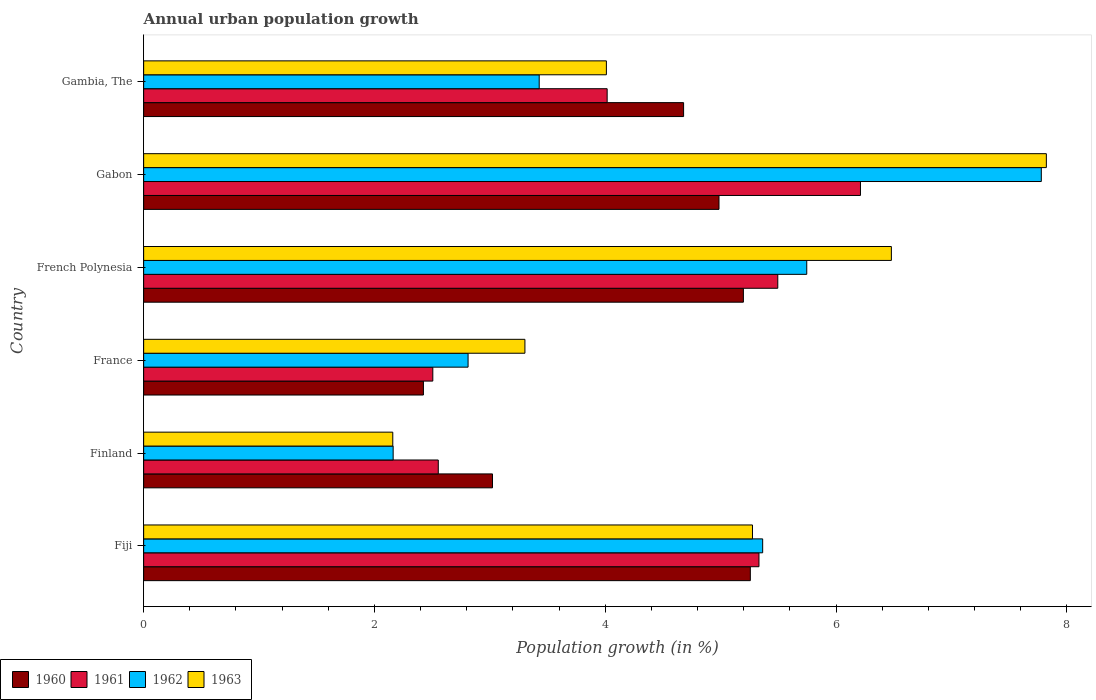How many different coloured bars are there?
Provide a short and direct response. 4. How many groups of bars are there?
Offer a terse response. 6. Are the number of bars per tick equal to the number of legend labels?
Your answer should be very brief. Yes. Are the number of bars on each tick of the Y-axis equal?
Provide a short and direct response. Yes. How many bars are there on the 2nd tick from the bottom?
Offer a terse response. 4. What is the label of the 2nd group of bars from the top?
Provide a succinct answer. Gabon. What is the percentage of urban population growth in 1960 in Gambia, The?
Offer a terse response. 4.68. Across all countries, what is the maximum percentage of urban population growth in 1962?
Your response must be concise. 7.78. Across all countries, what is the minimum percentage of urban population growth in 1963?
Your response must be concise. 2.16. In which country was the percentage of urban population growth in 1962 maximum?
Provide a short and direct response. Gabon. What is the total percentage of urban population growth in 1960 in the graph?
Keep it short and to the point. 25.57. What is the difference between the percentage of urban population growth in 1961 in Fiji and that in France?
Provide a short and direct response. 2.83. What is the difference between the percentage of urban population growth in 1961 in Fiji and the percentage of urban population growth in 1962 in Finland?
Keep it short and to the point. 3.17. What is the average percentage of urban population growth in 1961 per country?
Provide a short and direct response. 4.35. What is the difference between the percentage of urban population growth in 1962 and percentage of urban population growth in 1960 in Fiji?
Give a very brief answer. 0.11. What is the ratio of the percentage of urban population growth in 1963 in Fiji to that in Gabon?
Keep it short and to the point. 0.67. Is the difference between the percentage of urban population growth in 1962 in Finland and French Polynesia greater than the difference between the percentage of urban population growth in 1960 in Finland and French Polynesia?
Offer a very short reply. No. What is the difference between the highest and the second highest percentage of urban population growth in 1963?
Make the answer very short. 1.34. What is the difference between the highest and the lowest percentage of urban population growth in 1963?
Your response must be concise. 5.66. In how many countries, is the percentage of urban population growth in 1963 greater than the average percentage of urban population growth in 1963 taken over all countries?
Your answer should be compact. 3. Is it the case that in every country, the sum of the percentage of urban population growth in 1961 and percentage of urban population growth in 1963 is greater than the sum of percentage of urban population growth in 1962 and percentage of urban population growth in 1960?
Offer a terse response. No. What does the 1st bar from the top in France represents?
Keep it short and to the point. 1963. What does the 4th bar from the bottom in France represents?
Your answer should be compact. 1963. Is it the case that in every country, the sum of the percentage of urban population growth in 1963 and percentage of urban population growth in 1961 is greater than the percentage of urban population growth in 1962?
Offer a terse response. Yes. How many bars are there?
Offer a terse response. 24. Are all the bars in the graph horizontal?
Provide a succinct answer. Yes. Are the values on the major ticks of X-axis written in scientific E-notation?
Your response must be concise. No. Does the graph contain grids?
Keep it short and to the point. No. Where does the legend appear in the graph?
Give a very brief answer. Bottom left. How many legend labels are there?
Your answer should be compact. 4. How are the legend labels stacked?
Offer a terse response. Horizontal. What is the title of the graph?
Your answer should be very brief. Annual urban population growth. What is the label or title of the X-axis?
Provide a short and direct response. Population growth (in %). What is the label or title of the Y-axis?
Ensure brevity in your answer.  Country. What is the Population growth (in %) of 1960 in Fiji?
Keep it short and to the point. 5.26. What is the Population growth (in %) in 1961 in Fiji?
Offer a very short reply. 5.33. What is the Population growth (in %) of 1962 in Fiji?
Ensure brevity in your answer.  5.36. What is the Population growth (in %) in 1963 in Fiji?
Provide a succinct answer. 5.28. What is the Population growth (in %) of 1960 in Finland?
Offer a very short reply. 3.02. What is the Population growth (in %) of 1961 in Finland?
Your answer should be compact. 2.55. What is the Population growth (in %) in 1962 in Finland?
Make the answer very short. 2.16. What is the Population growth (in %) of 1963 in Finland?
Give a very brief answer. 2.16. What is the Population growth (in %) in 1960 in France?
Offer a terse response. 2.42. What is the Population growth (in %) in 1961 in France?
Give a very brief answer. 2.51. What is the Population growth (in %) of 1962 in France?
Offer a terse response. 2.81. What is the Population growth (in %) of 1963 in France?
Give a very brief answer. 3.3. What is the Population growth (in %) in 1960 in French Polynesia?
Offer a very short reply. 5.2. What is the Population growth (in %) in 1961 in French Polynesia?
Provide a short and direct response. 5.5. What is the Population growth (in %) in 1962 in French Polynesia?
Your response must be concise. 5.75. What is the Population growth (in %) in 1963 in French Polynesia?
Your response must be concise. 6.48. What is the Population growth (in %) in 1960 in Gabon?
Your response must be concise. 4.99. What is the Population growth (in %) in 1961 in Gabon?
Offer a terse response. 6.21. What is the Population growth (in %) of 1962 in Gabon?
Your answer should be very brief. 7.78. What is the Population growth (in %) in 1963 in Gabon?
Provide a succinct answer. 7.82. What is the Population growth (in %) of 1960 in Gambia, The?
Offer a terse response. 4.68. What is the Population growth (in %) in 1961 in Gambia, The?
Your response must be concise. 4.02. What is the Population growth (in %) in 1962 in Gambia, The?
Your answer should be very brief. 3.43. What is the Population growth (in %) in 1963 in Gambia, The?
Give a very brief answer. 4.01. Across all countries, what is the maximum Population growth (in %) in 1960?
Your response must be concise. 5.26. Across all countries, what is the maximum Population growth (in %) of 1961?
Offer a terse response. 6.21. Across all countries, what is the maximum Population growth (in %) of 1962?
Offer a very short reply. 7.78. Across all countries, what is the maximum Population growth (in %) in 1963?
Your response must be concise. 7.82. Across all countries, what is the minimum Population growth (in %) in 1960?
Offer a terse response. 2.42. Across all countries, what is the minimum Population growth (in %) of 1961?
Your response must be concise. 2.51. Across all countries, what is the minimum Population growth (in %) in 1962?
Your answer should be very brief. 2.16. Across all countries, what is the minimum Population growth (in %) in 1963?
Keep it short and to the point. 2.16. What is the total Population growth (in %) in 1960 in the graph?
Offer a terse response. 25.57. What is the total Population growth (in %) in 1961 in the graph?
Your answer should be very brief. 26.12. What is the total Population growth (in %) in 1962 in the graph?
Give a very brief answer. 27.29. What is the total Population growth (in %) in 1963 in the graph?
Give a very brief answer. 29.05. What is the difference between the Population growth (in %) of 1960 in Fiji and that in Finland?
Offer a terse response. 2.23. What is the difference between the Population growth (in %) in 1961 in Fiji and that in Finland?
Give a very brief answer. 2.78. What is the difference between the Population growth (in %) of 1962 in Fiji and that in Finland?
Ensure brevity in your answer.  3.2. What is the difference between the Population growth (in %) of 1963 in Fiji and that in Finland?
Provide a succinct answer. 3.12. What is the difference between the Population growth (in %) of 1960 in Fiji and that in France?
Provide a short and direct response. 2.83. What is the difference between the Population growth (in %) in 1961 in Fiji and that in France?
Make the answer very short. 2.83. What is the difference between the Population growth (in %) in 1962 in Fiji and that in France?
Ensure brevity in your answer.  2.55. What is the difference between the Population growth (in %) of 1963 in Fiji and that in France?
Provide a short and direct response. 1.97. What is the difference between the Population growth (in %) in 1960 in Fiji and that in French Polynesia?
Provide a succinct answer. 0.06. What is the difference between the Population growth (in %) of 1961 in Fiji and that in French Polynesia?
Keep it short and to the point. -0.16. What is the difference between the Population growth (in %) in 1962 in Fiji and that in French Polynesia?
Your response must be concise. -0.38. What is the difference between the Population growth (in %) in 1963 in Fiji and that in French Polynesia?
Your answer should be very brief. -1.2. What is the difference between the Population growth (in %) of 1960 in Fiji and that in Gabon?
Keep it short and to the point. 0.27. What is the difference between the Population growth (in %) in 1961 in Fiji and that in Gabon?
Make the answer very short. -0.88. What is the difference between the Population growth (in %) of 1962 in Fiji and that in Gabon?
Your answer should be compact. -2.41. What is the difference between the Population growth (in %) in 1963 in Fiji and that in Gabon?
Provide a short and direct response. -2.55. What is the difference between the Population growth (in %) in 1960 in Fiji and that in Gambia, The?
Provide a short and direct response. 0.58. What is the difference between the Population growth (in %) of 1961 in Fiji and that in Gambia, The?
Ensure brevity in your answer.  1.32. What is the difference between the Population growth (in %) of 1962 in Fiji and that in Gambia, The?
Give a very brief answer. 1.94. What is the difference between the Population growth (in %) in 1963 in Fiji and that in Gambia, The?
Keep it short and to the point. 1.27. What is the difference between the Population growth (in %) of 1960 in Finland and that in France?
Offer a terse response. 0.6. What is the difference between the Population growth (in %) in 1961 in Finland and that in France?
Provide a succinct answer. 0.05. What is the difference between the Population growth (in %) in 1962 in Finland and that in France?
Give a very brief answer. -0.65. What is the difference between the Population growth (in %) in 1963 in Finland and that in France?
Make the answer very short. -1.15. What is the difference between the Population growth (in %) in 1960 in Finland and that in French Polynesia?
Your answer should be very brief. -2.17. What is the difference between the Population growth (in %) in 1961 in Finland and that in French Polynesia?
Your response must be concise. -2.94. What is the difference between the Population growth (in %) of 1962 in Finland and that in French Polynesia?
Offer a terse response. -3.58. What is the difference between the Population growth (in %) in 1963 in Finland and that in French Polynesia?
Your answer should be compact. -4.32. What is the difference between the Population growth (in %) of 1960 in Finland and that in Gabon?
Keep it short and to the point. -1.96. What is the difference between the Population growth (in %) in 1961 in Finland and that in Gabon?
Your response must be concise. -3.66. What is the difference between the Population growth (in %) in 1962 in Finland and that in Gabon?
Offer a very short reply. -5.62. What is the difference between the Population growth (in %) in 1963 in Finland and that in Gabon?
Provide a short and direct response. -5.66. What is the difference between the Population growth (in %) in 1960 in Finland and that in Gambia, The?
Your response must be concise. -1.66. What is the difference between the Population growth (in %) of 1961 in Finland and that in Gambia, The?
Make the answer very short. -1.46. What is the difference between the Population growth (in %) in 1962 in Finland and that in Gambia, The?
Your answer should be very brief. -1.27. What is the difference between the Population growth (in %) in 1963 in Finland and that in Gambia, The?
Offer a terse response. -1.85. What is the difference between the Population growth (in %) in 1960 in France and that in French Polynesia?
Offer a terse response. -2.77. What is the difference between the Population growth (in %) of 1961 in France and that in French Polynesia?
Keep it short and to the point. -2.99. What is the difference between the Population growth (in %) in 1962 in France and that in French Polynesia?
Offer a terse response. -2.94. What is the difference between the Population growth (in %) in 1963 in France and that in French Polynesia?
Provide a succinct answer. -3.18. What is the difference between the Population growth (in %) in 1960 in France and that in Gabon?
Give a very brief answer. -2.56. What is the difference between the Population growth (in %) in 1961 in France and that in Gabon?
Ensure brevity in your answer.  -3.71. What is the difference between the Population growth (in %) in 1962 in France and that in Gabon?
Make the answer very short. -4.97. What is the difference between the Population growth (in %) of 1963 in France and that in Gabon?
Your answer should be compact. -4.52. What is the difference between the Population growth (in %) of 1960 in France and that in Gambia, The?
Your response must be concise. -2.25. What is the difference between the Population growth (in %) of 1961 in France and that in Gambia, The?
Offer a very short reply. -1.51. What is the difference between the Population growth (in %) in 1962 in France and that in Gambia, The?
Your answer should be very brief. -0.62. What is the difference between the Population growth (in %) in 1963 in France and that in Gambia, The?
Ensure brevity in your answer.  -0.71. What is the difference between the Population growth (in %) of 1960 in French Polynesia and that in Gabon?
Offer a very short reply. 0.21. What is the difference between the Population growth (in %) of 1961 in French Polynesia and that in Gabon?
Keep it short and to the point. -0.72. What is the difference between the Population growth (in %) in 1962 in French Polynesia and that in Gabon?
Your answer should be very brief. -2.03. What is the difference between the Population growth (in %) of 1963 in French Polynesia and that in Gabon?
Make the answer very short. -1.34. What is the difference between the Population growth (in %) of 1960 in French Polynesia and that in Gambia, The?
Keep it short and to the point. 0.52. What is the difference between the Population growth (in %) of 1961 in French Polynesia and that in Gambia, The?
Ensure brevity in your answer.  1.48. What is the difference between the Population growth (in %) of 1962 in French Polynesia and that in Gambia, The?
Provide a succinct answer. 2.32. What is the difference between the Population growth (in %) of 1963 in French Polynesia and that in Gambia, The?
Provide a succinct answer. 2.47. What is the difference between the Population growth (in %) in 1960 in Gabon and that in Gambia, The?
Provide a short and direct response. 0.31. What is the difference between the Population growth (in %) in 1961 in Gabon and that in Gambia, The?
Your response must be concise. 2.2. What is the difference between the Population growth (in %) in 1962 in Gabon and that in Gambia, The?
Your answer should be very brief. 4.35. What is the difference between the Population growth (in %) in 1963 in Gabon and that in Gambia, The?
Ensure brevity in your answer.  3.81. What is the difference between the Population growth (in %) in 1960 in Fiji and the Population growth (in %) in 1961 in Finland?
Give a very brief answer. 2.7. What is the difference between the Population growth (in %) in 1960 in Fiji and the Population growth (in %) in 1962 in Finland?
Provide a short and direct response. 3.1. What is the difference between the Population growth (in %) in 1960 in Fiji and the Population growth (in %) in 1963 in Finland?
Make the answer very short. 3.1. What is the difference between the Population growth (in %) in 1961 in Fiji and the Population growth (in %) in 1962 in Finland?
Ensure brevity in your answer.  3.17. What is the difference between the Population growth (in %) of 1961 in Fiji and the Population growth (in %) of 1963 in Finland?
Offer a terse response. 3.17. What is the difference between the Population growth (in %) of 1962 in Fiji and the Population growth (in %) of 1963 in Finland?
Make the answer very short. 3.21. What is the difference between the Population growth (in %) of 1960 in Fiji and the Population growth (in %) of 1961 in France?
Your answer should be very brief. 2.75. What is the difference between the Population growth (in %) in 1960 in Fiji and the Population growth (in %) in 1962 in France?
Offer a terse response. 2.45. What is the difference between the Population growth (in %) of 1960 in Fiji and the Population growth (in %) of 1963 in France?
Your answer should be compact. 1.95. What is the difference between the Population growth (in %) of 1961 in Fiji and the Population growth (in %) of 1962 in France?
Your answer should be very brief. 2.52. What is the difference between the Population growth (in %) of 1961 in Fiji and the Population growth (in %) of 1963 in France?
Provide a short and direct response. 2.03. What is the difference between the Population growth (in %) in 1962 in Fiji and the Population growth (in %) in 1963 in France?
Give a very brief answer. 2.06. What is the difference between the Population growth (in %) of 1960 in Fiji and the Population growth (in %) of 1961 in French Polynesia?
Your response must be concise. -0.24. What is the difference between the Population growth (in %) in 1960 in Fiji and the Population growth (in %) in 1962 in French Polynesia?
Offer a very short reply. -0.49. What is the difference between the Population growth (in %) in 1960 in Fiji and the Population growth (in %) in 1963 in French Polynesia?
Ensure brevity in your answer.  -1.22. What is the difference between the Population growth (in %) in 1961 in Fiji and the Population growth (in %) in 1962 in French Polynesia?
Ensure brevity in your answer.  -0.41. What is the difference between the Population growth (in %) in 1961 in Fiji and the Population growth (in %) in 1963 in French Polynesia?
Ensure brevity in your answer.  -1.15. What is the difference between the Population growth (in %) of 1962 in Fiji and the Population growth (in %) of 1963 in French Polynesia?
Ensure brevity in your answer.  -1.12. What is the difference between the Population growth (in %) of 1960 in Fiji and the Population growth (in %) of 1961 in Gabon?
Keep it short and to the point. -0.95. What is the difference between the Population growth (in %) of 1960 in Fiji and the Population growth (in %) of 1962 in Gabon?
Keep it short and to the point. -2.52. What is the difference between the Population growth (in %) in 1960 in Fiji and the Population growth (in %) in 1963 in Gabon?
Keep it short and to the point. -2.57. What is the difference between the Population growth (in %) of 1961 in Fiji and the Population growth (in %) of 1962 in Gabon?
Provide a succinct answer. -2.45. What is the difference between the Population growth (in %) in 1961 in Fiji and the Population growth (in %) in 1963 in Gabon?
Keep it short and to the point. -2.49. What is the difference between the Population growth (in %) in 1962 in Fiji and the Population growth (in %) in 1963 in Gabon?
Offer a very short reply. -2.46. What is the difference between the Population growth (in %) of 1960 in Fiji and the Population growth (in %) of 1961 in Gambia, The?
Offer a very short reply. 1.24. What is the difference between the Population growth (in %) in 1960 in Fiji and the Population growth (in %) in 1962 in Gambia, The?
Ensure brevity in your answer.  1.83. What is the difference between the Population growth (in %) in 1960 in Fiji and the Population growth (in %) in 1963 in Gambia, The?
Your answer should be very brief. 1.25. What is the difference between the Population growth (in %) in 1961 in Fiji and the Population growth (in %) in 1962 in Gambia, The?
Offer a very short reply. 1.9. What is the difference between the Population growth (in %) of 1961 in Fiji and the Population growth (in %) of 1963 in Gambia, The?
Keep it short and to the point. 1.32. What is the difference between the Population growth (in %) of 1962 in Fiji and the Population growth (in %) of 1963 in Gambia, The?
Offer a terse response. 1.35. What is the difference between the Population growth (in %) of 1960 in Finland and the Population growth (in %) of 1961 in France?
Your answer should be very brief. 0.52. What is the difference between the Population growth (in %) in 1960 in Finland and the Population growth (in %) in 1962 in France?
Ensure brevity in your answer.  0.21. What is the difference between the Population growth (in %) in 1960 in Finland and the Population growth (in %) in 1963 in France?
Keep it short and to the point. -0.28. What is the difference between the Population growth (in %) of 1961 in Finland and the Population growth (in %) of 1962 in France?
Make the answer very short. -0.26. What is the difference between the Population growth (in %) of 1961 in Finland and the Population growth (in %) of 1963 in France?
Your answer should be compact. -0.75. What is the difference between the Population growth (in %) of 1962 in Finland and the Population growth (in %) of 1963 in France?
Your response must be concise. -1.14. What is the difference between the Population growth (in %) in 1960 in Finland and the Population growth (in %) in 1961 in French Polynesia?
Your answer should be very brief. -2.47. What is the difference between the Population growth (in %) in 1960 in Finland and the Population growth (in %) in 1962 in French Polynesia?
Your answer should be very brief. -2.72. What is the difference between the Population growth (in %) of 1960 in Finland and the Population growth (in %) of 1963 in French Polynesia?
Make the answer very short. -3.46. What is the difference between the Population growth (in %) in 1961 in Finland and the Population growth (in %) in 1962 in French Polynesia?
Ensure brevity in your answer.  -3.19. What is the difference between the Population growth (in %) in 1961 in Finland and the Population growth (in %) in 1963 in French Polynesia?
Keep it short and to the point. -3.93. What is the difference between the Population growth (in %) of 1962 in Finland and the Population growth (in %) of 1963 in French Polynesia?
Ensure brevity in your answer.  -4.32. What is the difference between the Population growth (in %) in 1960 in Finland and the Population growth (in %) in 1961 in Gabon?
Your answer should be very brief. -3.19. What is the difference between the Population growth (in %) of 1960 in Finland and the Population growth (in %) of 1962 in Gabon?
Your answer should be very brief. -4.76. What is the difference between the Population growth (in %) of 1960 in Finland and the Population growth (in %) of 1963 in Gabon?
Your answer should be very brief. -4.8. What is the difference between the Population growth (in %) in 1961 in Finland and the Population growth (in %) in 1962 in Gabon?
Your answer should be compact. -5.23. What is the difference between the Population growth (in %) of 1961 in Finland and the Population growth (in %) of 1963 in Gabon?
Offer a very short reply. -5.27. What is the difference between the Population growth (in %) in 1962 in Finland and the Population growth (in %) in 1963 in Gabon?
Provide a short and direct response. -5.66. What is the difference between the Population growth (in %) of 1960 in Finland and the Population growth (in %) of 1961 in Gambia, The?
Offer a very short reply. -0.99. What is the difference between the Population growth (in %) in 1960 in Finland and the Population growth (in %) in 1962 in Gambia, The?
Your response must be concise. -0.4. What is the difference between the Population growth (in %) of 1960 in Finland and the Population growth (in %) of 1963 in Gambia, The?
Your answer should be compact. -0.99. What is the difference between the Population growth (in %) in 1961 in Finland and the Population growth (in %) in 1962 in Gambia, The?
Provide a short and direct response. -0.87. What is the difference between the Population growth (in %) of 1961 in Finland and the Population growth (in %) of 1963 in Gambia, The?
Your answer should be very brief. -1.46. What is the difference between the Population growth (in %) of 1962 in Finland and the Population growth (in %) of 1963 in Gambia, The?
Offer a very short reply. -1.85. What is the difference between the Population growth (in %) in 1960 in France and the Population growth (in %) in 1961 in French Polynesia?
Provide a short and direct response. -3.07. What is the difference between the Population growth (in %) in 1960 in France and the Population growth (in %) in 1962 in French Polynesia?
Your answer should be very brief. -3.32. What is the difference between the Population growth (in %) in 1960 in France and the Population growth (in %) in 1963 in French Polynesia?
Offer a very short reply. -4.06. What is the difference between the Population growth (in %) in 1961 in France and the Population growth (in %) in 1962 in French Polynesia?
Your response must be concise. -3.24. What is the difference between the Population growth (in %) of 1961 in France and the Population growth (in %) of 1963 in French Polynesia?
Provide a short and direct response. -3.97. What is the difference between the Population growth (in %) of 1962 in France and the Population growth (in %) of 1963 in French Polynesia?
Keep it short and to the point. -3.67. What is the difference between the Population growth (in %) in 1960 in France and the Population growth (in %) in 1961 in Gabon?
Ensure brevity in your answer.  -3.79. What is the difference between the Population growth (in %) in 1960 in France and the Population growth (in %) in 1962 in Gabon?
Provide a succinct answer. -5.35. What is the difference between the Population growth (in %) of 1960 in France and the Population growth (in %) of 1963 in Gabon?
Offer a very short reply. -5.4. What is the difference between the Population growth (in %) of 1961 in France and the Population growth (in %) of 1962 in Gabon?
Offer a very short reply. -5.27. What is the difference between the Population growth (in %) of 1961 in France and the Population growth (in %) of 1963 in Gabon?
Provide a short and direct response. -5.32. What is the difference between the Population growth (in %) of 1962 in France and the Population growth (in %) of 1963 in Gabon?
Provide a short and direct response. -5.01. What is the difference between the Population growth (in %) in 1960 in France and the Population growth (in %) in 1961 in Gambia, The?
Keep it short and to the point. -1.59. What is the difference between the Population growth (in %) of 1960 in France and the Population growth (in %) of 1962 in Gambia, The?
Offer a terse response. -1. What is the difference between the Population growth (in %) of 1960 in France and the Population growth (in %) of 1963 in Gambia, The?
Provide a short and direct response. -1.59. What is the difference between the Population growth (in %) in 1961 in France and the Population growth (in %) in 1962 in Gambia, The?
Provide a short and direct response. -0.92. What is the difference between the Population growth (in %) in 1961 in France and the Population growth (in %) in 1963 in Gambia, The?
Ensure brevity in your answer.  -1.5. What is the difference between the Population growth (in %) of 1962 in France and the Population growth (in %) of 1963 in Gambia, The?
Make the answer very short. -1.2. What is the difference between the Population growth (in %) in 1960 in French Polynesia and the Population growth (in %) in 1961 in Gabon?
Ensure brevity in your answer.  -1.01. What is the difference between the Population growth (in %) of 1960 in French Polynesia and the Population growth (in %) of 1962 in Gabon?
Offer a terse response. -2.58. What is the difference between the Population growth (in %) in 1960 in French Polynesia and the Population growth (in %) in 1963 in Gabon?
Your response must be concise. -2.63. What is the difference between the Population growth (in %) in 1961 in French Polynesia and the Population growth (in %) in 1962 in Gabon?
Keep it short and to the point. -2.28. What is the difference between the Population growth (in %) of 1961 in French Polynesia and the Population growth (in %) of 1963 in Gabon?
Your response must be concise. -2.33. What is the difference between the Population growth (in %) in 1962 in French Polynesia and the Population growth (in %) in 1963 in Gabon?
Make the answer very short. -2.08. What is the difference between the Population growth (in %) in 1960 in French Polynesia and the Population growth (in %) in 1961 in Gambia, The?
Offer a very short reply. 1.18. What is the difference between the Population growth (in %) of 1960 in French Polynesia and the Population growth (in %) of 1962 in Gambia, The?
Your response must be concise. 1.77. What is the difference between the Population growth (in %) in 1960 in French Polynesia and the Population growth (in %) in 1963 in Gambia, The?
Make the answer very short. 1.19. What is the difference between the Population growth (in %) of 1961 in French Polynesia and the Population growth (in %) of 1962 in Gambia, The?
Ensure brevity in your answer.  2.07. What is the difference between the Population growth (in %) of 1961 in French Polynesia and the Population growth (in %) of 1963 in Gambia, The?
Make the answer very short. 1.49. What is the difference between the Population growth (in %) in 1962 in French Polynesia and the Population growth (in %) in 1963 in Gambia, The?
Provide a short and direct response. 1.74. What is the difference between the Population growth (in %) in 1960 in Gabon and the Population growth (in %) in 1961 in Gambia, The?
Keep it short and to the point. 0.97. What is the difference between the Population growth (in %) of 1960 in Gabon and the Population growth (in %) of 1962 in Gambia, The?
Provide a short and direct response. 1.56. What is the difference between the Population growth (in %) of 1960 in Gabon and the Population growth (in %) of 1963 in Gambia, The?
Provide a short and direct response. 0.98. What is the difference between the Population growth (in %) of 1961 in Gabon and the Population growth (in %) of 1962 in Gambia, The?
Keep it short and to the point. 2.78. What is the difference between the Population growth (in %) in 1961 in Gabon and the Population growth (in %) in 1963 in Gambia, The?
Offer a very short reply. 2.2. What is the difference between the Population growth (in %) in 1962 in Gabon and the Population growth (in %) in 1963 in Gambia, The?
Offer a terse response. 3.77. What is the average Population growth (in %) of 1960 per country?
Your answer should be compact. 4.26. What is the average Population growth (in %) of 1961 per country?
Give a very brief answer. 4.35. What is the average Population growth (in %) in 1962 per country?
Your answer should be very brief. 4.55. What is the average Population growth (in %) of 1963 per country?
Your answer should be compact. 4.84. What is the difference between the Population growth (in %) in 1960 and Population growth (in %) in 1961 in Fiji?
Your response must be concise. -0.07. What is the difference between the Population growth (in %) in 1960 and Population growth (in %) in 1962 in Fiji?
Ensure brevity in your answer.  -0.11. What is the difference between the Population growth (in %) in 1960 and Population growth (in %) in 1963 in Fiji?
Your response must be concise. -0.02. What is the difference between the Population growth (in %) in 1961 and Population growth (in %) in 1962 in Fiji?
Your answer should be compact. -0.03. What is the difference between the Population growth (in %) in 1961 and Population growth (in %) in 1963 in Fiji?
Make the answer very short. 0.06. What is the difference between the Population growth (in %) of 1962 and Population growth (in %) of 1963 in Fiji?
Keep it short and to the point. 0.09. What is the difference between the Population growth (in %) of 1960 and Population growth (in %) of 1961 in Finland?
Offer a terse response. 0.47. What is the difference between the Population growth (in %) in 1960 and Population growth (in %) in 1962 in Finland?
Provide a succinct answer. 0.86. What is the difference between the Population growth (in %) in 1960 and Population growth (in %) in 1963 in Finland?
Keep it short and to the point. 0.86. What is the difference between the Population growth (in %) in 1961 and Population growth (in %) in 1962 in Finland?
Provide a succinct answer. 0.39. What is the difference between the Population growth (in %) of 1961 and Population growth (in %) of 1963 in Finland?
Offer a terse response. 0.39. What is the difference between the Population growth (in %) in 1962 and Population growth (in %) in 1963 in Finland?
Make the answer very short. 0. What is the difference between the Population growth (in %) of 1960 and Population growth (in %) of 1961 in France?
Offer a very short reply. -0.08. What is the difference between the Population growth (in %) in 1960 and Population growth (in %) in 1962 in France?
Provide a short and direct response. -0.39. What is the difference between the Population growth (in %) in 1960 and Population growth (in %) in 1963 in France?
Offer a very short reply. -0.88. What is the difference between the Population growth (in %) of 1961 and Population growth (in %) of 1962 in France?
Provide a succinct answer. -0.31. What is the difference between the Population growth (in %) in 1961 and Population growth (in %) in 1963 in France?
Your answer should be very brief. -0.8. What is the difference between the Population growth (in %) of 1962 and Population growth (in %) of 1963 in France?
Give a very brief answer. -0.49. What is the difference between the Population growth (in %) of 1960 and Population growth (in %) of 1961 in French Polynesia?
Your answer should be very brief. -0.3. What is the difference between the Population growth (in %) in 1960 and Population growth (in %) in 1962 in French Polynesia?
Your answer should be compact. -0.55. What is the difference between the Population growth (in %) in 1960 and Population growth (in %) in 1963 in French Polynesia?
Offer a terse response. -1.28. What is the difference between the Population growth (in %) of 1961 and Population growth (in %) of 1962 in French Polynesia?
Your answer should be very brief. -0.25. What is the difference between the Population growth (in %) in 1961 and Population growth (in %) in 1963 in French Polynesia?
Make the answer very short. -0.98. What is the difference between the Population growth (in %) of 1962 and Population growth (in %) of 1963 in French Polynesia?
Give a very brief answer. -0.73. What is the difference between the Population growth (in %) in 1960 and Population growth (in %) in 1961 in Gabon?
Give a very brief answer. -1.23. What is the difference between the Population growth (in %) of 1960 and Population growth (in %) of 1962 in Gabon?
Give a very brief answer. -2.79. What is the difference between the Population growth (in %) of 1960 and Population growth (in %) of 1963 in Gabon?
Your response must be concise. -2.84. What is the difference between the Population growth (in %) of 1961 and Population growth (in %) of 1962 in Gabon?
Give a very brief answer. -1.57. What is the difference between the Population growth (in %) in 1961 and Population growth (in %) in 1963 in Gabon?
Ensure brevity in your answer.  -1.61. What is the difference between the Population growth (in %) in 1962 and Population growth (in %) in 1963 in Gabon?
Ensure brevity in your answer.  -0.04. What is the difference between the Population growth (in %) in 1960 and Population growth (in %) in 1961 in Gambia, The?
Give a very brief answer. 0.66. What is the difference between the Population growth (in %) of 1960 and Population growth (in %) of 1962 in Gambia, The?
Your response must be concise. 1.25. What is the difference between the Population growth (in %) in 1960 and Population growth (in %) in 1963 in Gambia, The?
Keep it short and to the point. 0.67. What is the difference between the Population growth (in %) of 1961 and Population growth (in %) of 1962 in Gambia, The?
Make the answer very short. 0.59. What is the difference between the Population growth (in %) of 1961 and Population growth (in %) of 1963 in Gambia, The?
Keep it short and to the point. 0.01. What is the difference between the Population growth (in %) in 1962 and Population growth (in %) in 1963 in Gambia, The?
Offer a terse response. -0.58. What is the ratio of the Population growth (in %) in 1960 in Fiji to that in Finland?
Make the answer very short. 1.74. What is the ratio of the Population growth (in %) in 1961 in Fiji to that in Finland?
Your answer should be very brief. 2.09. What is the ratio of the Population growth (in %) of 1962 in Fiji to that in Finland?
Keep it short and to the point. 2.48. What is the ratio of the Population growth (in %) in 1963 in Fiji to that in Finland?
Your answer should be very brief. 2.44. What is the ratio of the Population growth (in %) in 1960 in Fiji to that in France?
Offer a very short reply. 2.17. What is the ratio of the Population growth (in %) in 1961 in Fiji to that in France?
Keep it short and to the point. 2.13. What is the ratio of the Population growth (in %) of 1962 in Fiji to that in France?
Your answer should be very brief. 1.91. What is the ratio of the Population growth (in %) in 1963 in Fiji to that in France?
Give a very brief answer. 1.6. What is the ratio of the Population growth (in %) of 1960 in Fiji to that in French Polynesia?
Your response must be concise. 1.01. What is the ratio of the Population growth (in %) of 1961 in Fiji to that in French Polynesia?
Provide a succinct answer. 0.97. What is the ratio of the Population growth (in %) in 1962 in Fiji to that in French Polynesia?
Ensure brevity in your answer.  0.93. What is the ratio of the Population growth (in %) of 1963 in Fiji to that in French Polynesia?
Your answer should be very brief. 0.81. What is the ratio of the Population growth (in %) in 1960 in Fiji to that in Gabon?
Offer a very short reply. 1.05. What is the ratio of the Population growth (in %) in 1961 in Fiji to that in Gabon?
Your response must be concise. 0.86. What is the ratio of the Population growth (in %) of 1962 in Fiji to that in Gabon?
Keep it short and to the point. 0.69. What is the ratio of the Population growth (in %) in 1963 in Fiji to that in Gabon?
Give a very brief answer. 0.67. What is the ratio of the Population growth (in %) of 1960 in Fiji to that in Gambia, The?
Offer a terse response. 1.12. What is the ratio of the Population growth (in %) in 1961 in Fiji to that in Gambia, The?
Keep it short and to the point. 1.33. What is the ratio of the Population growth (in %) in 1962 in Fiji to that in Gambia, The?
Make the answer very short. 1.56. What is the ratio of the Population growth (in %) of 1963 in Fiji to that in Gambia, The?
Keep it short and to the point. 1.32. What is the ratio of the Population growth (in %) of 1960 in Finland to that in France?
Provide a succinct answer. 1.25. What is the ratio of the Population growth (in %) of 1961 in Finland to that in France?
Provide a succinct answer. 1.02. What is the ratio of the Population growth (in %) of 1962 in Finland to that in France?
Make the answer very short. 0.77. What is the ratio of the Population growth (in %) of 1963 in Finland to that in France?
Give a very brief answer. 0.65. What is the ratio of the Population growth (in %) in 1960 in Finland to that in French Polynesia?
Provide a short and direct response. 0.58. What is the ratio of the Population growth (in %) of 1961 in Finland to that in French Polynesia?
Provide a short and direct response. 0.46. What is the ratio of the Population growth (in %) of 1962 in Finland to that in French Polynesia?
Offer a very short reply. 0.38. What is the ratio of the Population growth (in %) in 1963 in Finland to that in French Polynesia?
Provide a succinct answer. 0.33. What is the ratio of the Population growth (in %) in 1960 in Finland to that in Gabon?
Offer a terse response. 0.61. What is the ratio of the Population growth (in %) in 1961 in Finland to that in Gabon?
Offer a terse response. 0.41. What is the ratio of the Population growth (in %) of 1962 in Finland to that in Gabon?
Give a very brief answer. 0.28. What is the ratio of the Population growth (in %) of 1963 in Finland to that in Gabon?
Provide a short and direct response. 0.28. What is the ratio of the Population growth (in %) of 1960 in Finland to that in Gambia, The?
Offer a terse response. 0.65. What is the ratio of the Population growth (in %) of 1961 in Finland to that in Gambia, The?
Keep it short and to the point. 0.64. What is the ratio of the Population growth (in %) of 1962 in Finland to that in Gambia, The?
Offer a terse response. 0.63. What is the ratio of the Population growth (in %) of 1963 in Finland to that in Gambia, The?
Ensure brevity in your answer.  0.54. What is the ratio of the Population growth (in %) in 1960 in France to that in French Polynesia?
Offer a very short reply. 0.47. What is the ratio of the Population growth (in %) in 1961 in France to that in French Polynesia?
Offer a very short reply. 0.46. What is the ratio of the Population growth (in %) of 1962 in France to that in French Polynesia?
Your answer should be compact. 0.49. What is the ratio of the Population growth (in %) in 1963 in France to that in French Polynesia?
Provide a short and direct response. 0.51. What is the ratio of the Population growth (in %) of 1960 in France to that in Gabon?
Offer a very short reply. 0.49. What is the ratio of the Population growth (in %) of 1961 in France to that in Gabon?
Offer a terse response. 0.4. What is the ratio of the Population growth (in %) of 1962 in France to that in Gabon?
Provide a succinct answer. 0.36. What is the ratio of the Population growth (in %) in 1963 in France to that in Gabon?
Make the answer very short. 0.42. What is the ratio of the Population growth (in %) in 1960 in France to that in Gambia, The?
Make the answer very short. 0.52. What is the ratio of the Population growth (in %) of 1961 in France to that in Gambia, The?
Give a very brief answer. 0.62. What is the ratio of the Population growth (in %) in 1962 in France to that in Gambia, The?
Make the answer very short. 0.82. What is the ratio of the Population growth (in %) in 1963 in France to that in Gambia, The?
Your answer should be very brief. 0.82. What is the ratio of the Population growth (in %) in 1960 in French Polynesia to that in Gabon?
Ensure brevity in your answer.  1.04. What is the ratio of the Population growth (in %) in 1961 in French Polynesia to that in Gabon?
Provide a short and direct response. 0.88. What is the ratio of the Population growth (in %) of 1962 in French Polynesia to that in Gabon?
Your answer should be compact. 0.74. What is the ratio of the Population growth (in %) of 1963 in French Polynesia to that in Gabon?
Give a very brief answer. 0.83. What is the ratio of the Population growth (in %) of 1960 in French Polynesia to that in Gambia, The?
Offer a very short reply. 1.11. What is the ratio of the Population growth (in %) in 1961 in French Polynesia to that in Gambia, The?
Your answer should be very brief. 1.37. What is the ratio of the Population growth (in %) in 1962 in French Polynesia to that in Gambia, The?
Your answer should be very brief. 1.68. What is the ratio of the Population growth (in %) in 1963 in French Polynesia to that in Gambia, The?
Offer a very short reply. 1.62. What is the ratio of the Population growth (in %) in 1960 in Gabon to that in Gambia, The?
Make the answer very short. 1.07. What is the ratio of the Population growth (in %) in 1961 in Gabon to that in Gambia, The?
Give a very brief answer. 1.55. What is the ratio of the Population growth (in %) in 1962 in Gabon to that in Gambia, The?
Offer a very short reply. 2.27. What is the ratio of the Population growth (in %) of 1963 in Gabon to that in Gambia, The?
Your answer should be compact. 1.95. What is the difference between the highest and the second highest Population growth (in %) in 1960?
Your response must be concise. 0.06. What is the difference between the highest and the second highest Population growth (in %) in 1961?
Offer a very short reply. 0.72. What is the difference between the highest and the second highest Population growth (in %) of 1962?
Your answer should be compact. 2.03. What is the difference between the highest and the second highest Population growth (in %) in 1963?
Provide a succinct answer. 1.34. What is the difference between the highest and the lowest Population growth (in %) of 1960?
Offer a terse response. 2.83. What is the difference between the highest and the lowest Population growth (in %) of 1961?
Make the answer very short. 3.71. What is the difference between the highest and the lowest Population growth (in %) in 1962?
Provide a succinct answer. 5.62. What is the difference between the highest and the lowest Population growth (in %) of 1963?
Offer a very short reply. 5.66. 